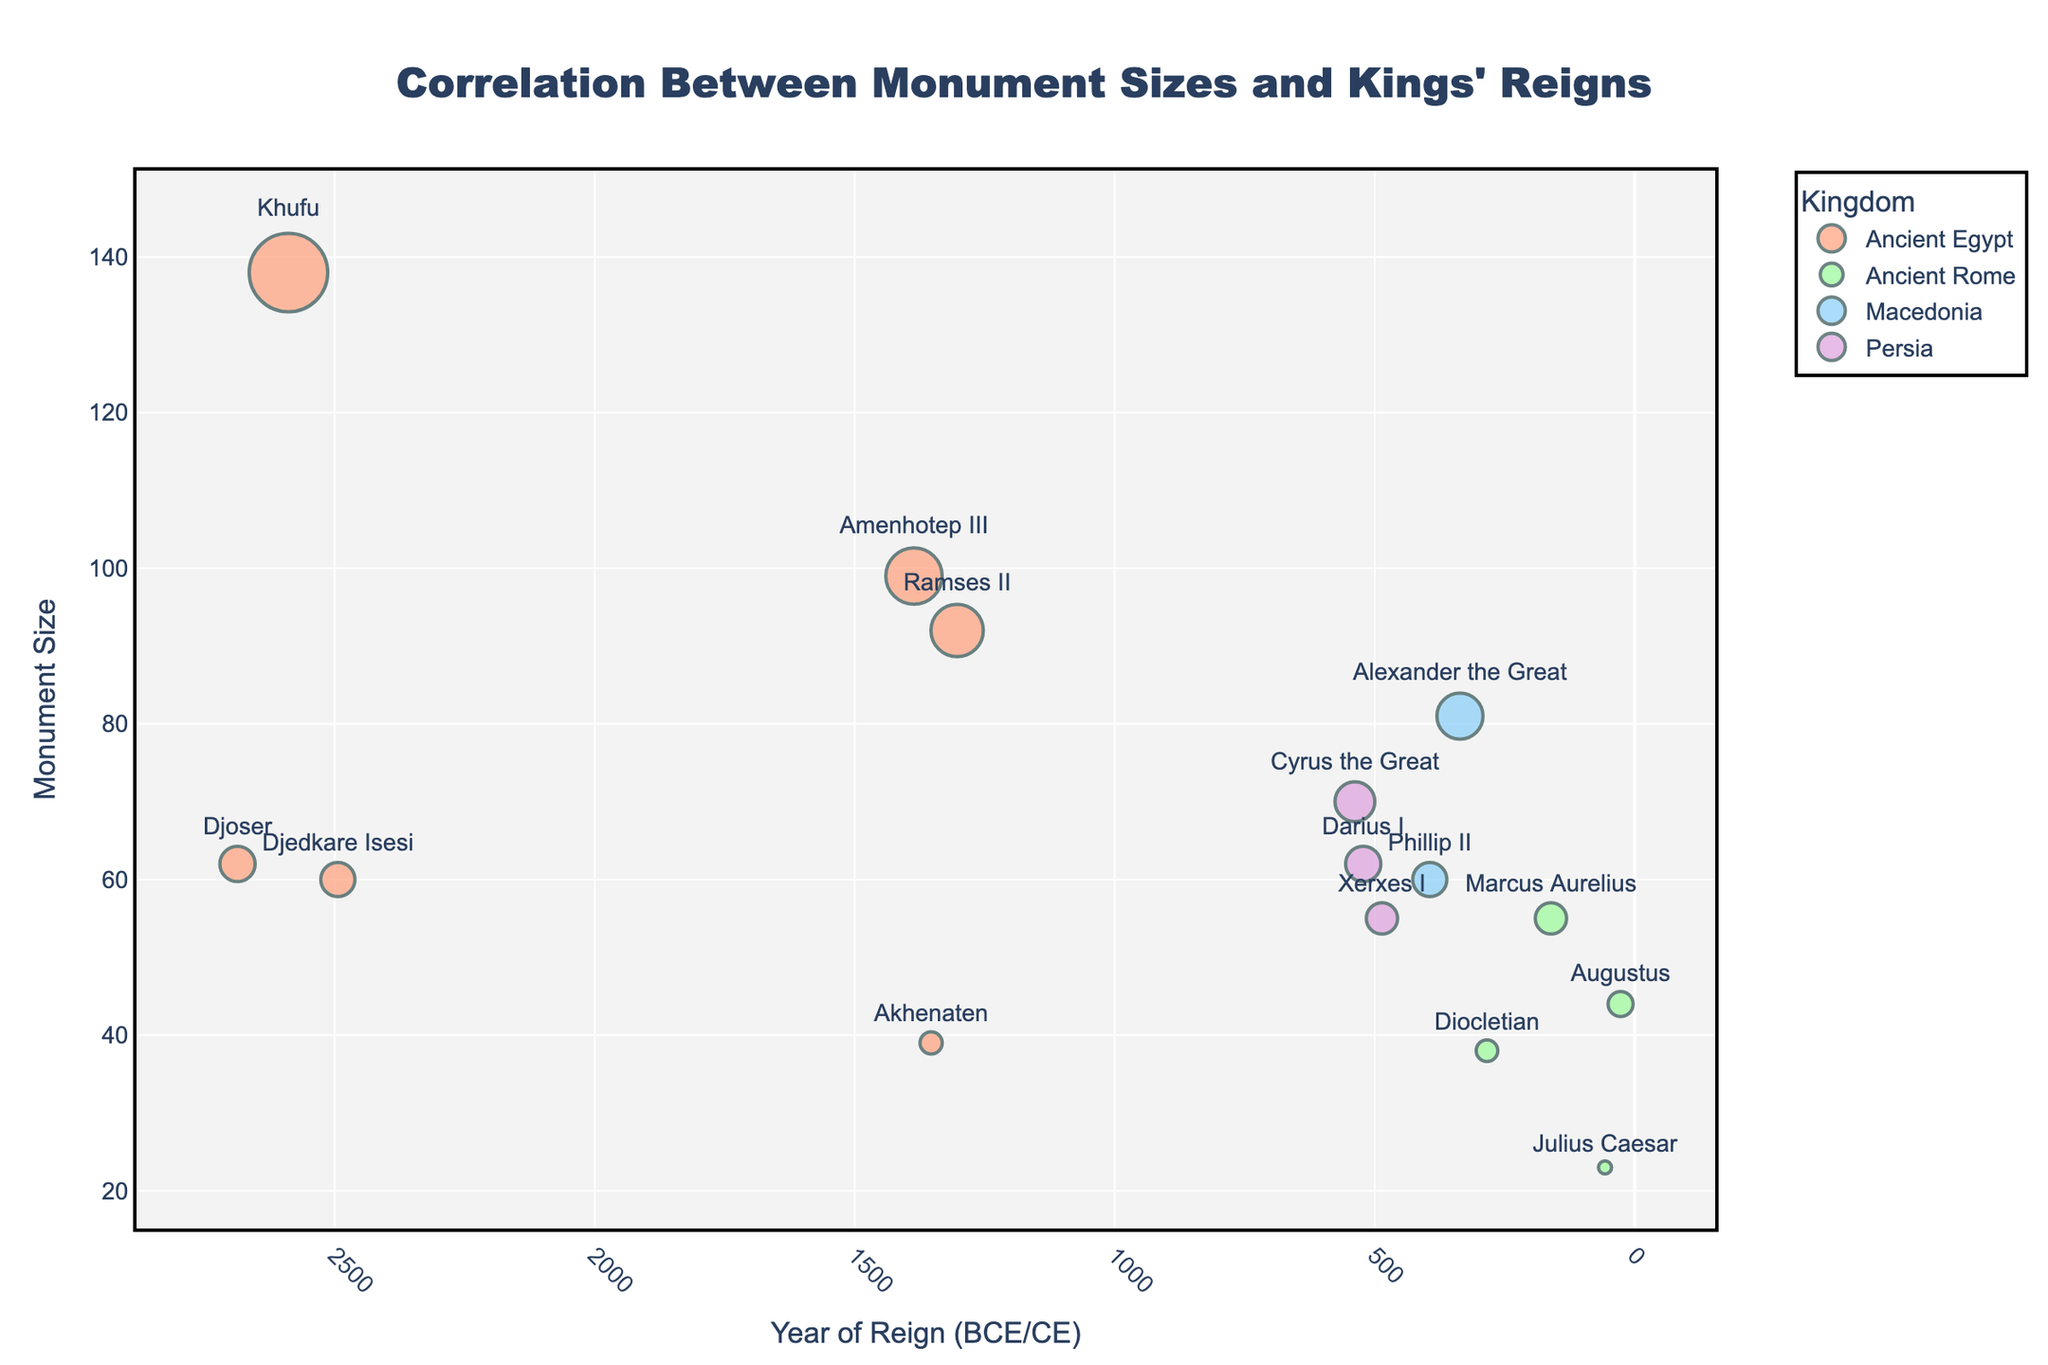what is the title of the figure? The title is displayed at the top of the figure and provides an overview of its content. In this case, the title is about the correlation between monument sizes and kings' reigns.
Answer: Correlation Between Monument Sizes and Kings' Reigns How many data points are there for Ancient Egypt? Look for the data points marked with the color designated for Ancient Egypt (likely light salmon). Count these points on the plot.
Answer: 6 Which kingdom has the largest monument size and who was the monarch during that reign? Check the y-axis to identify the largest monument size and locate the corresponding data point with its color and label.
Answer: Ancient Egypt, Khufu What is the range of years covered by monarchs in Ancient Rome? Identify the earliest and latest reign years among the data points plotted for Ancient Rome (likely green points). Subtract the earliest from the latest to find the range.
Answer: 57 BCE to 305 CE Who had the smallest monument size and which kingdom did they belong to? Identify the data point with the smallest value on the y-axis and note the monarch and kingdom associated with this point.
Answer: Julius Caesar, Ancient Rome What is the average monument size for kings from Ancient Egypt? Find all the monument sizes for Ancient Egypt, sum them up, and divide by the number of these kings to get the average.
Answer: (62 + 138 + 60 + 99 + 39 + 92) / 6 = 81.6667 Which kingdom has the most monarchs listed? Compare the number of data points for each kingdom represented on the plot.
Answer: Ancient Egypt What is the difference in monument size between Cyrus the Great and Xerxes I? Locate the monument sizes for Cyrus the Great and Xerxes I from Persia and subtract the smaller size from the bigger one.
Answer: 70 - 55 = 15 Which monarch had a reign starting closest to 0 CE and what was the monument size during their reign? Identify the data point closest to 0 CE on the x-axis and note the corresponding monarch and monument size.
Answer: Augustus, 44 Was monument size generally larger in earlier or later periods within the scope of this data? Observe the trend in monument sizes by comparing the values across the different reign periods, noting any general increase or decrease over time.
Answer: Earlier periods 